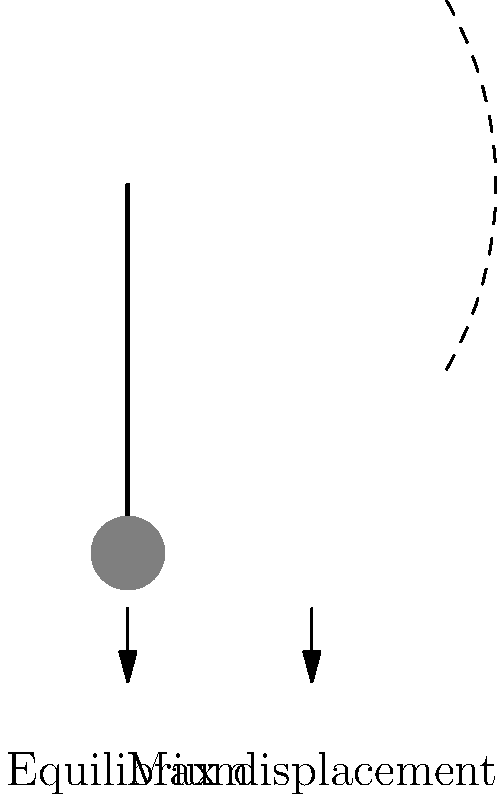In the pendulum diagram, what physical quantity does the arc represent, and how does it relate to the author's minimalist style? 1. The arc in the diagram represents the path of the pendulum bob's motion.
2. This motion is an example of simple harmonic motion (SHM).
3. The arc illustrates the amplitude of the pendulum's oscillation.
4. Amplitude is the maximum displacement from the equilibrium position.
5. In SHM, the restoring force is proportional to the displacement.
6. This relationship leads to the characteristic back-and-forth motion.
7. The arc's simplicity mirrors the author's minimalist narrative style.
8. Both the arc and minimalist writing convey complex ideas with economy.
9. The pendulum's motion, like concise prose, is elegant in its simplicity.
10. The arc efficiently represents the essence of the pendulum's behavior, just as minimalist writing captures the core of a story.
Answer: Amplitude 